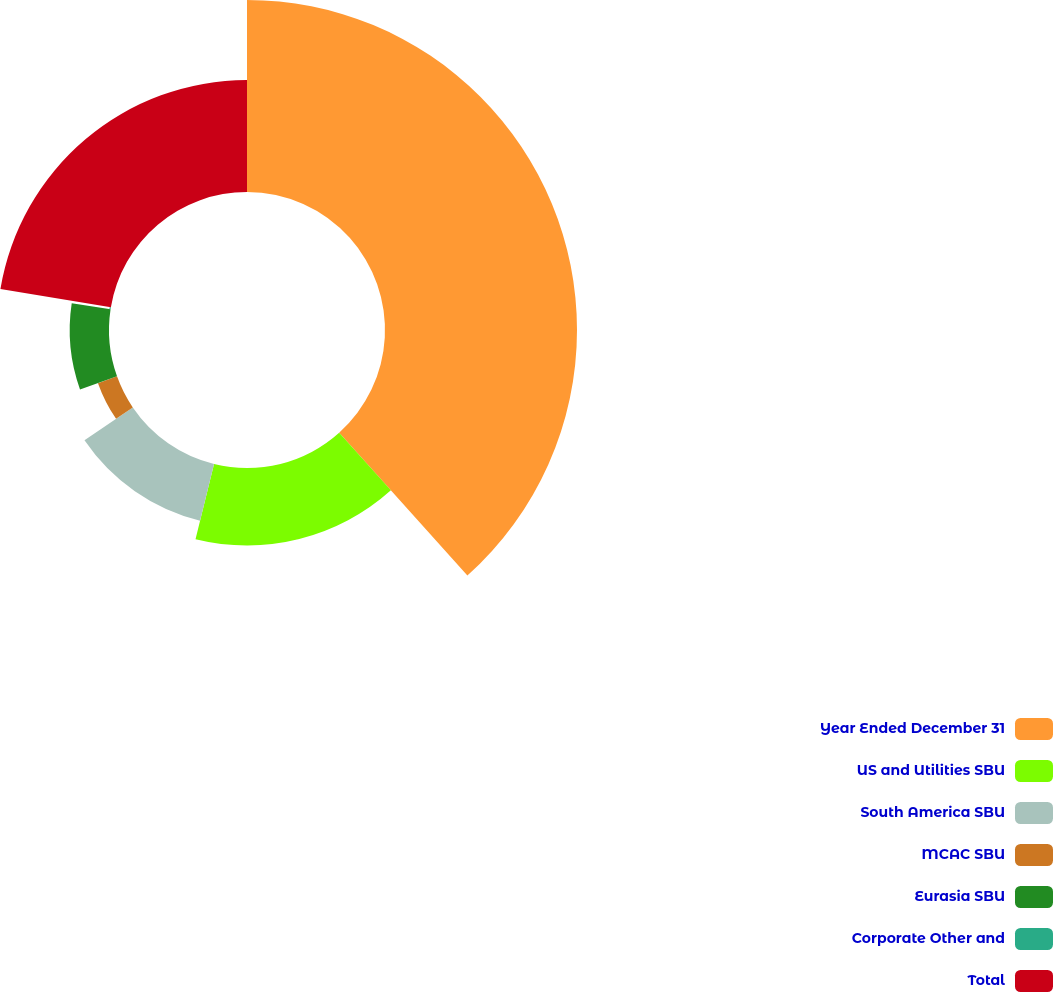<chart> <loc_0><loc_0><loc_500><loc_500><pie_chart><fcel>Year Ended December 31<fcel>US and Utilities SBU<fcel>South America SBU<fcel>MCAC SBU<fcel>Eurasia SBU<fcel>Corporate Other and<fcel>Total<nl><fcel>38.36%<fcel>15.48%<fcel>11.67%<fcel>4.04%<fcel>7.85%<fcel>0.23%<fcel>22.37%<nl></chart> 